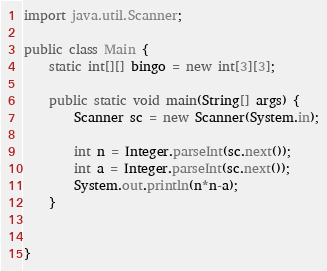<code> <loc_0><loc_0><loc_500><loc_500><_Java_>import java.util.Scanner;

public class Main {
	static int[][] bingo = new int[3][3];

	public static void main(String[] args) {
		Scanner sc = new Scanner(System.in);

		int n = Integer.parseInt(sc.next());
		int a = Integer.parseInt(sc.next());
		System.out.println(n*n-a);
	}


}
</code> 